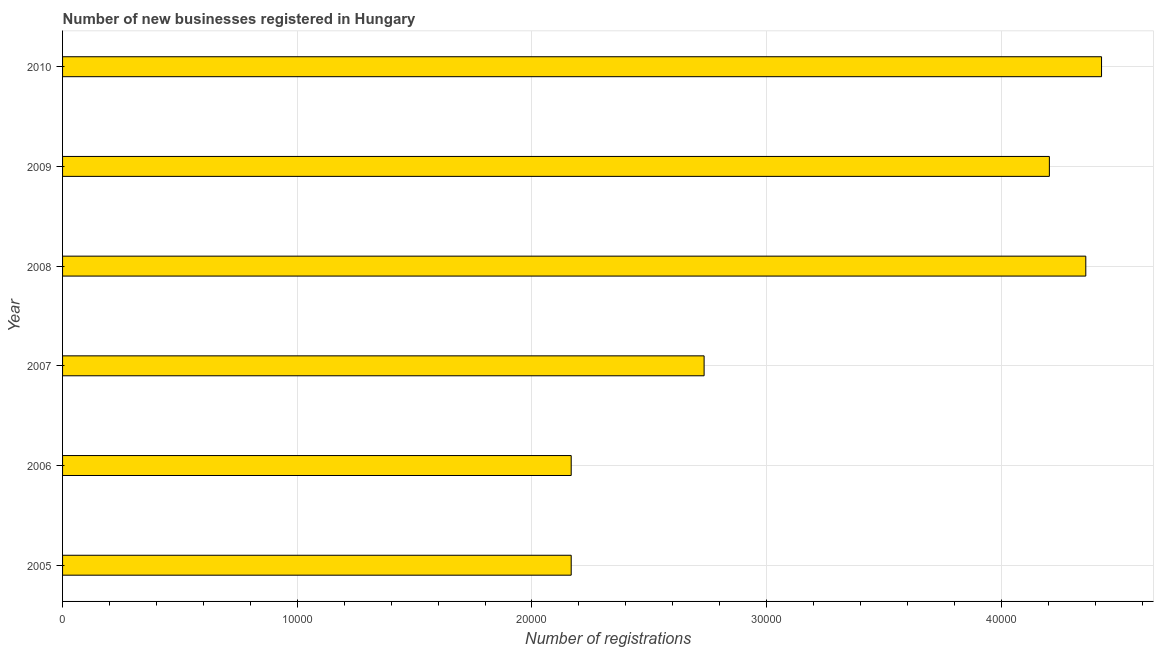Does the graph contain any zero values?
Your answer should be compact. No. Does the graph contain grids?
Keep it short and to the point. Yes. What is the title of the graph?
Ensure brevity in your answer.  Number of new businesses registered in Hungary. What is the label or title of the X-axis?
Provide a short and direct response. Number of registrations. What is the number of new business registrations in 2008?
Your answer should be very brief. 4.36e+04. Across all years, what is the maximum number of new business registrations?
Offer a very short reply. 4.43e+04. Across all years, what is the minimum number of new business registrations?
Offer a very short reply. 2.17e+04. In which year was the number of new business registrations minimum?
Your answer should be compact. 2005. What is the sum of the number of new business registrations?
Provide a succinct answer. 2.01e+05. What is the difference between the number of new business registrations in 2006 and 2008?
Ensure brevity in your answer.  -2.19e+04. What is the average number of new business registrations per year?
Your answer should be very brief. 3.34e+04. What is the median number of new business registrations?
Offer a terse response. 3.47e+04. In how many years, is the number of new business registrations greater than 40000 ?
Offer a very short reply. 3. Do a majority of the years between 2009 and 2007 (inclusive) have number of new business registrations greater than 26000 ?
Keep it short and to the point. Yes. What is the ratio of the number of new business registrations in 2005 to that in 2010?
Provide a short and direct response. 0.49. What is the difference between the highest and the second highest number of new business registrations?
Your answer should be compact. 671. What is the difference between the highest and the lowest number of new business registrations?
Make the answer very short. 2.26e+04. How many bars are there?
Your answer should be very brief. 6. Are all the bars in the graph horizontal?
Offer a terse response. Yes. How many years are there in the graph?
Ensure brevity in your answer.  6. What is the difference between two consecutive major ticks on the X-axis?
Make the answer very short. 10000. What is the Number of registrations of 2005?
Your response must be concise. 2.17e+04. What is the Number of registrations of 2006?
Make the answer very short. 2.17e+04. What is the Number of registrations of 2007?
Provide a short and direct response. 2.73e+04. What is the Number of registrations of 2008?
Give a very brief answer. 4.36e+04. What is the Number of registrations of 2009?
Keep it short and to the point. 4.20e+04. What is the Number of registrations of 2010?
Ensure brevity in your answer.  4.43e+04. What is the difference between the Number of registrations in 2005 and 2006?
Provide a succinct answer. 0. What is the difference between the Number of registrations in 2005 and 2007?
Provide a short and direct response. -5663. What is the difference between the Number of registrations in 2005 and 2008?
Ensure brevity in your answer.  -2.19e+04. What is the difference between the Number of registrations in 2005 and 2009?
Offer a terse response. -2.04e+04. What is the difference between the Number of registrations in 2005 and 2010?
Offer a very short reply. -2.26e+04. What is the difference between the Number of registrations in 2006 and 2007?
Your answer should be compact. -5663. What is the difference between the Number of registrations in 2006 and 2008?
Make the answer very short. -2.19e+04. What is the difference between the Number of registrations in 2006 and 2009?
Keep it short and to the point. -2.04e+04. What is the difference between the Number of registrations in 2006 and 2010?
Your answer should be very brief. -2.26e+04. What is the difference between the Number of registrations in 2007 and 2008?
Offer a terse response. -1.63e+04. What is the difference between the Number of registrations in 2007 and 2009?
Make the answer very short. -1.47e+04. What is the difference between the Number of registrations in 2007 and 2010?
Keep it short and to the point. -1.69e+04. What is the difference between the Number of registrations in 2008 and 2009?
Provide a succinct answer. 1552. What is the difference between the Number of registrations in 2008 and 2010?
Offer a very short reply. -671. What is the difference between the Number of registrations in 2009 and 2010?
Ensure brevity in your answer.  -2223. What is the ratio of the Number of registrations in 2005 to that in 2006?
Provide a succinct answer. 1. What is the ratio of the Number of registrations in 2005 to that in 2007?
Offer a terse response. 0.79. What is the ratio of the Number of registrations in 2005 to that in 2008?
Ensure brevity in your answer.  0.5. What is the ratio of the Number of registrations in 2005 to that in 2009?
Offer a terse response. 0.52. What is the ratio of the Number of registrations in 2005 to that in 2010?
Keep it short and to the point. 0.49. What is the ratio of the Number of registrations in 2006 to that in 2007?
Keep it short and to the point. 0.79. What is the ratio of the Number of registrations in 2006 to that in 2008?
Make the answer very short. 0.5. What is the ratio of the Number of registrations in 2006 to that in 2009?
Provide a short and direct response. 0.52. What is the ratio of the Number of registrations in 2006 to that in 2010?
Give a very brief answer. 0.49. What is the ratio of the Number of registrations in 2007 to that in 2008?
Give a very brief answer. 0.63. What is the ratio of the Number of registrations in 2007 to that in 2009?
Make the answer very short. 0.65. What is the ratio of the Number of registrations in 2007 to that in 2010?
Offer a very short reply. 0.62. What is the ratio of the Number of registrations in 2008 to that in 2010?
Give a very brief answer. 0.98. What is the ratio of the Number of registrations in 2009 to that in 2010?
Offer a very short reply. 0.95. 